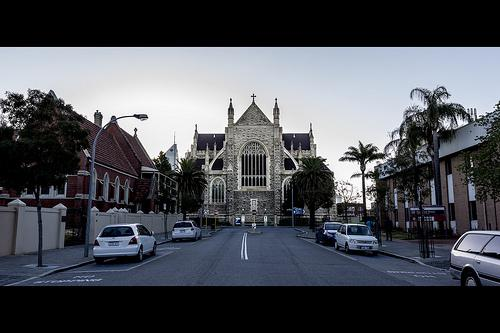Question: what part of town is there?
Choices:
A. Restaurant row.
B. City.
C. Skid row.
D. Musuem district.
Answer with the letter. Answer: B Question: where are the cars?
Choices:
A. Garage.
B. Parking space.
C. On the street.
D. Driveway.
Answer with the letter. Answer: B Question: what are the cars parked beside?
Choices:
A. Sidewalk.
B. Parking meters.
C. Other cars.
D. Buildings.
Answer with the letter. Answer: A Question: what color are the buildings?
Choices:
A. Brown.
B. Red.
C. Blue.
D. White.
Answer with the letter. Answer: A Question: what building is in the distance?
Choices:
A. School.
B. Church.
C. Bank.
D. Jail.
Answer with the letter. Answer: B 